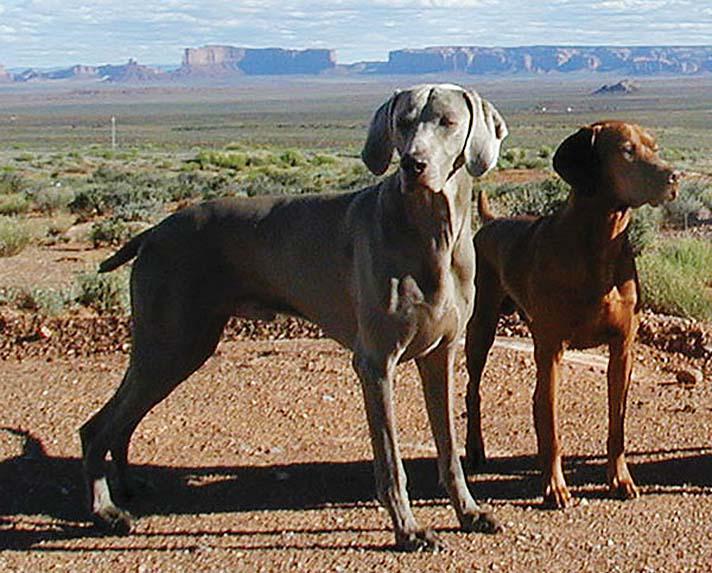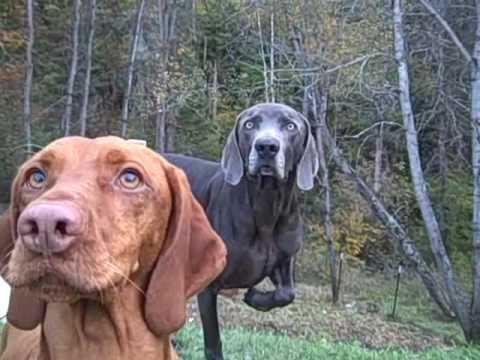The first image is the image on the left, the second image is the image on the right. Analyze the images presented: Is the assertion "There are exactly two dogs in both images." valid? Answer yes or no. Yes. The first image is the image on the left, the second image is the image on the right. For the images displayed, is the sentence "The left image shows a brown dog and a gray dog." factually correct? Answer yes or no. Yes. 